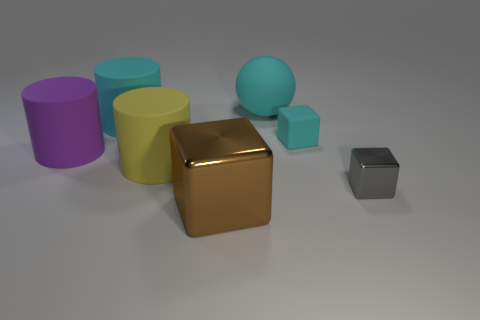How many big rubber objects are left of the cyan rubber cylinder and behind the cyan rubber cylinder? In viewing the arrangement of objects, there are no big rubber objects located to the left and behind the cyan cylinder. The area in question is completely devoid of objects, ensuring a clear space. 